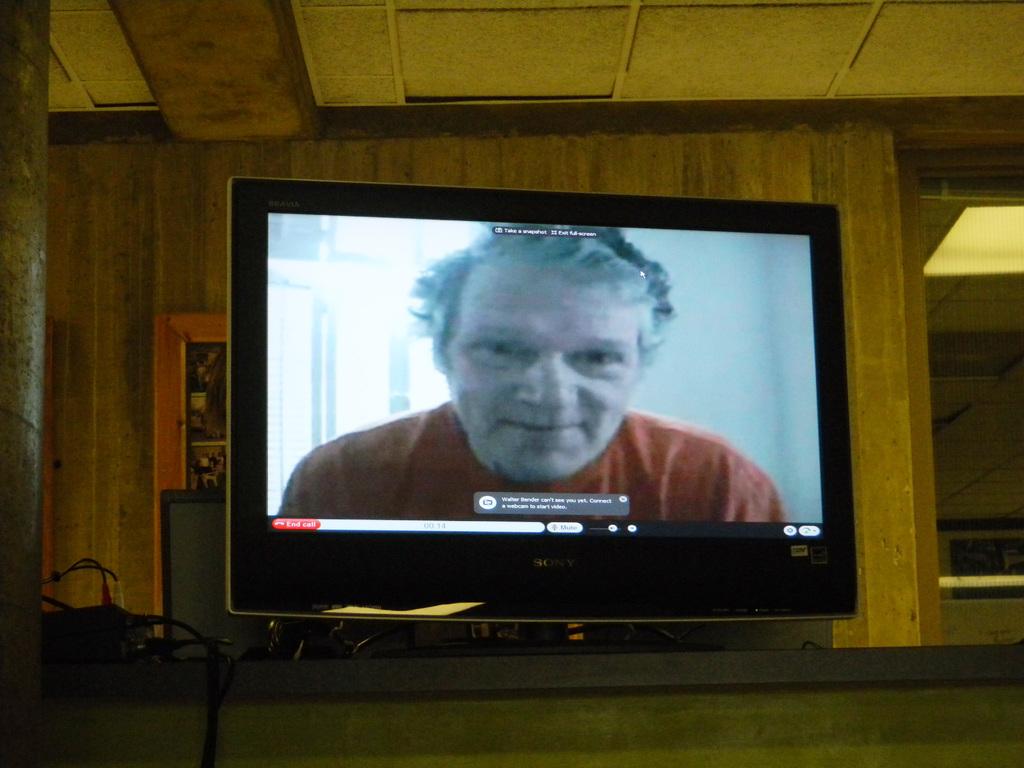What brand of monitor is this?
Provide a short and direct response. Sony. 